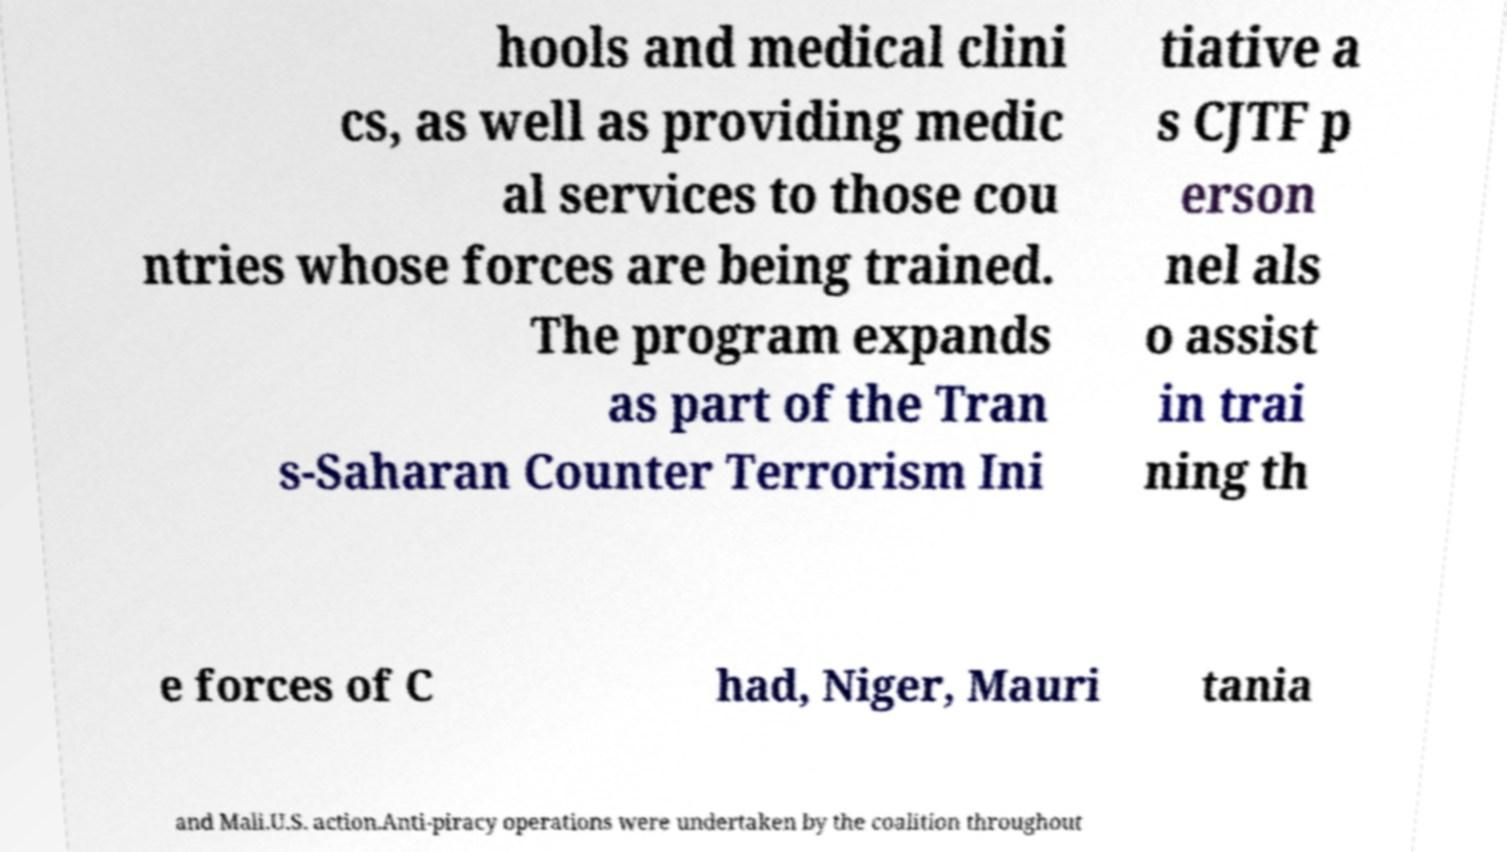Please identify and transcribe the text found in this image. hools and medical clini cs, as well as providing medic al services to those cou ntries whose forces are being trained. The program expands as part of the Tran s-Saharan Counter Terrorism Ini tiative a s CJTF p erson nel als o assist in trai ning th e forces of C had, Niger, Mauri tania and Mali.U.S. action.Anti-piracy operations were undertaken by the coalition throughout 